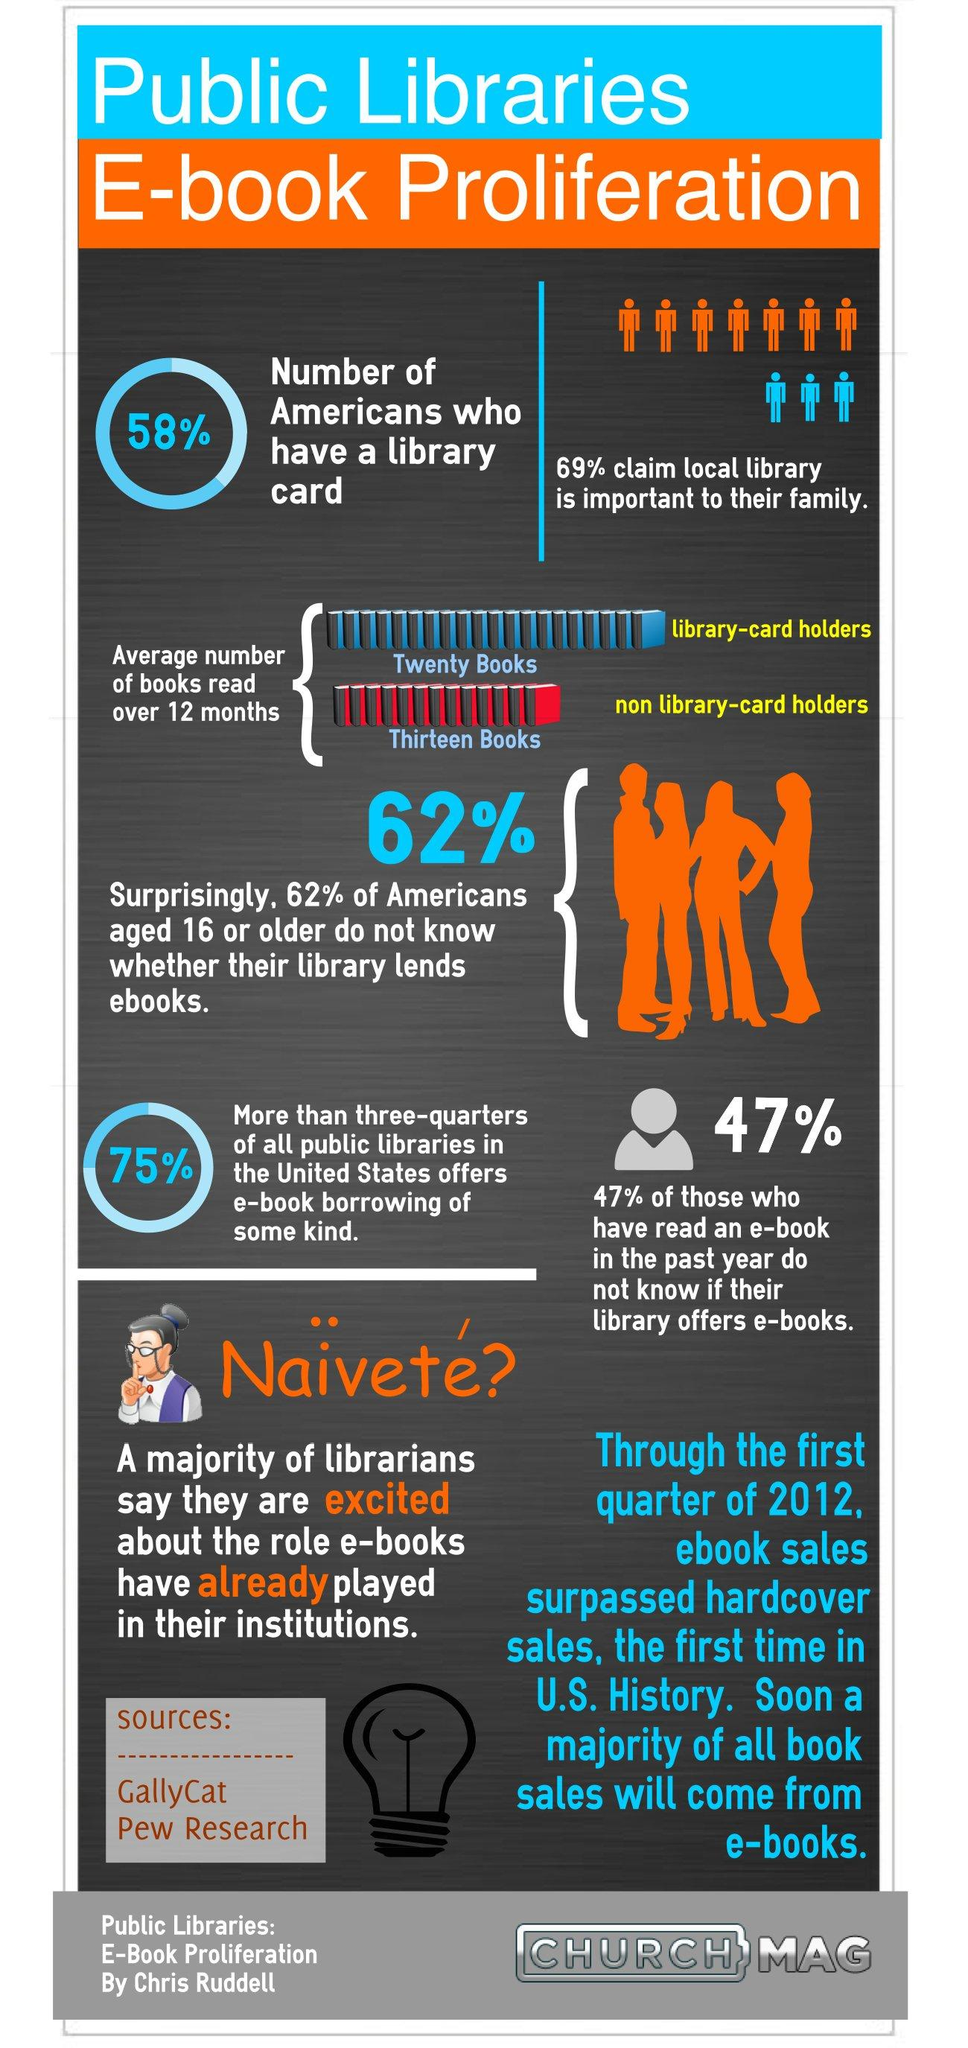Give some essential details in this illustration. A staggering 42% of Americans do not have a library card, indicating widespread disregard for the importance of access to information and resources. 